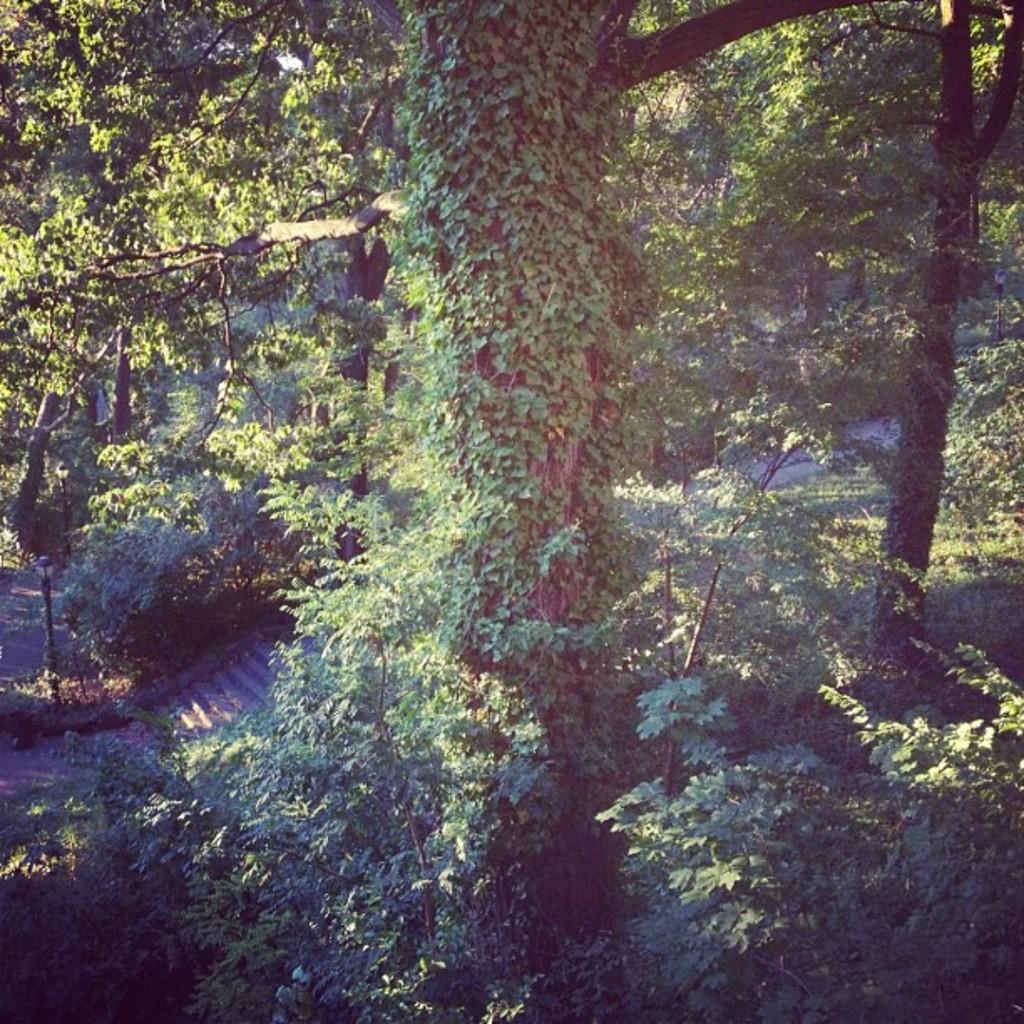What type of natural environment is depicted in the image? The image contains a forest. What are the main features of the forest? There are many trees, plants, and bushes in the image. Is there any man-made structure visible in the image? Yes, there is a road in the image. Are there any artificial light sources in the image? Yes, there are two lights attached to two poles in the image. What type of cap is the sink wearing in the image? There is no sink or cap present in the image. How does the forest help with arithmetic in the image? The forest does not help with arithmetic in the image; it is a natural environment and not related to mathematical calculations. 